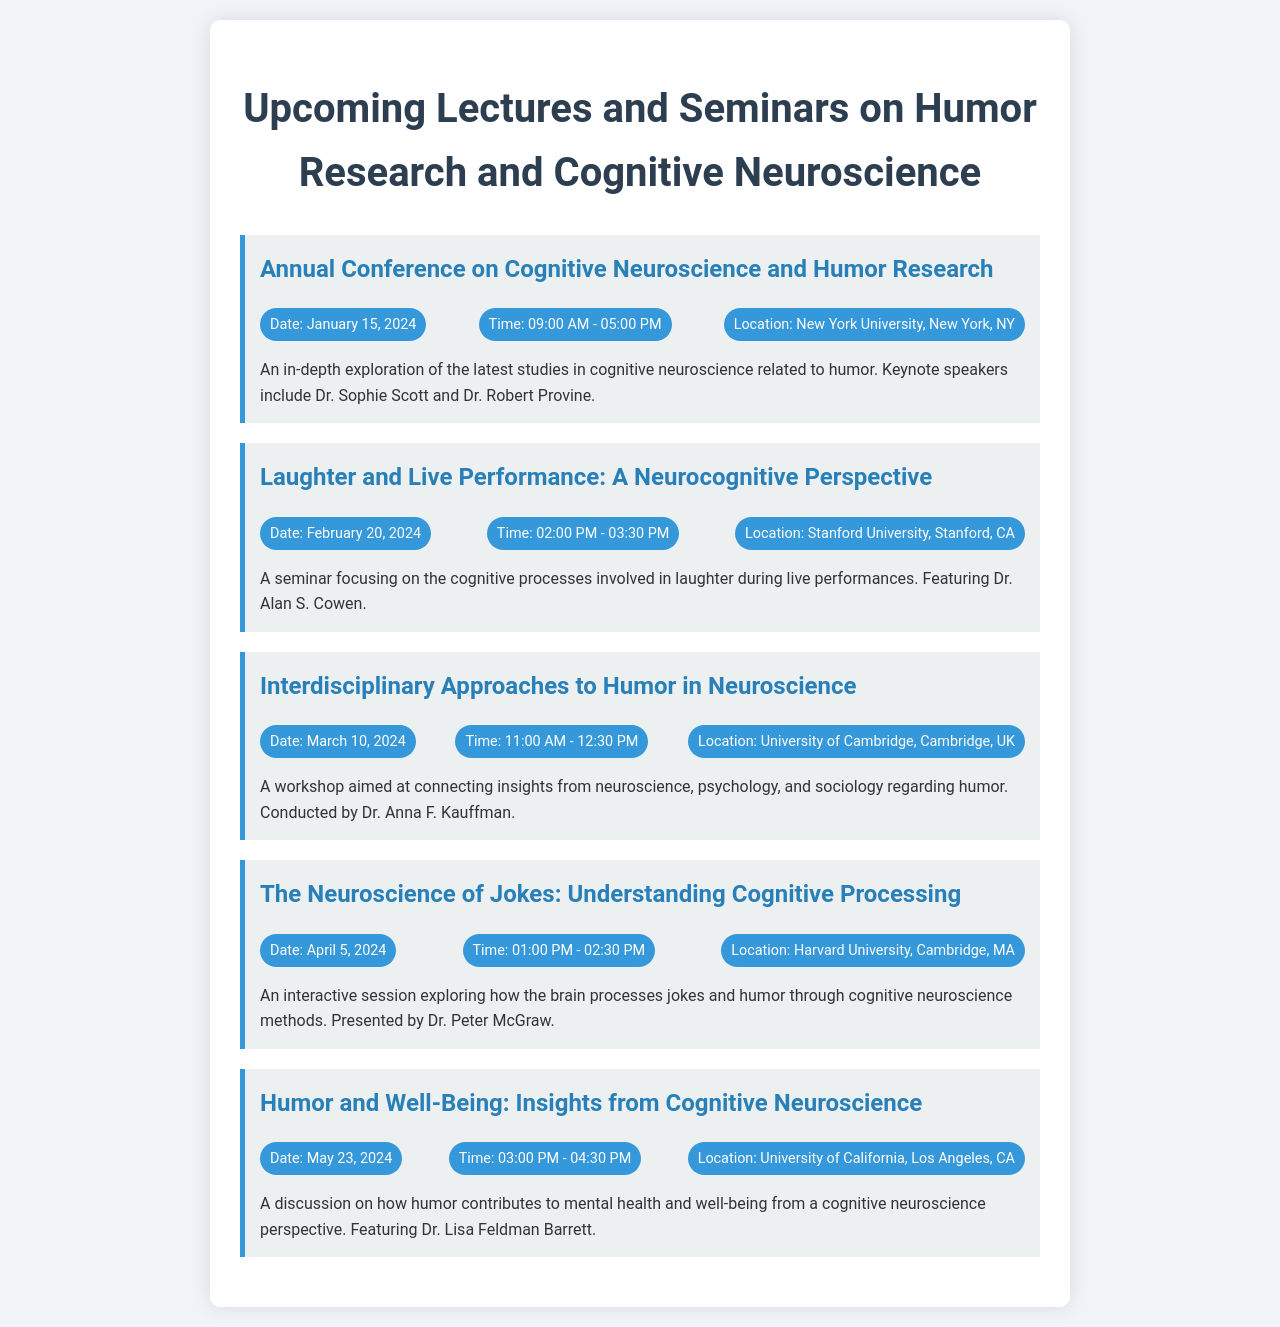What is the date of the Annual Conference? The date is specified in the event details.
Answer: January 15, 2024 Who is presenting at the seminar on Laughter and Live Performance? The presenters are mentioned in the event description.
Answer: Dr. Alan S. Cowen How long is the Interdisciplinary Approaches to Humor in Neuroscience workshop? The duration is provided in the event details.
Answer: 1 hour 30 minutes What cognitive process is discussed in The Neuroscience of Jokes session? The focus of the session is outlined in the description.
Answer: Cognitive processing Where is the Humor and Well-Being seminar taking place? The location is indicated in the event details.
Answer: University of California, Los Angeles, CA Which university hosts the Laughter and Live Performance seminar? The hosting university is mentioned under this event.
Answer: Stanford University Who are the keynote speakers at the Annual Conference? The speakers are listed in the event description.
Answer: Dr. Sophie Scott and Dr. Robert Provine What time does the Humor and Well-Being seminar start? The start time is included in the event details.
Answer: 03:00 PM 